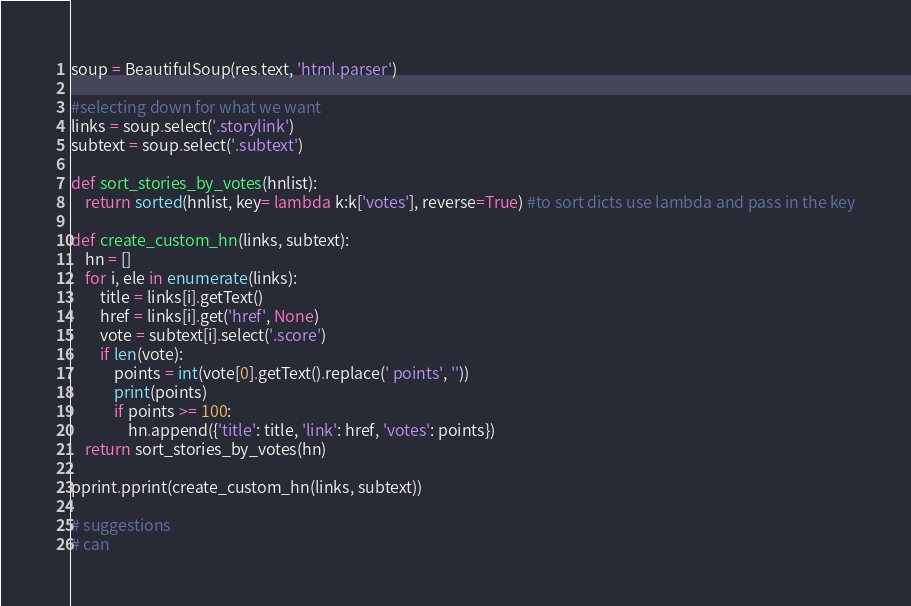Convert code to text. <code><loc_0><loc_0><loc_500><loc_500><_Python_>soup = BeautifulSoup(res.text, 'html.parser')

#selecting down for what we want 
links = soup.select('.storylink')
subtext = soup.select('.subtext')

def sort_stories_by_votes(hnlist):
    return sorted(hnlist, key= lambda k:k['votes'], reverse=True) #to sort dicts use lambda and pass in the key

def create_custom_hn(links, subtext):
    hn = []
    for i, ele in enumerate(links):
        title = links[i].getText()
        href = links[i].get('href', None)
        vote = subtext[i].select('.score')
        if len(vote):
            points = int(vote[0].getText().replace(' points', ''))
            print(points)
            if points >= 100:
                hn.append({'title': title, 'link': href, 'votes': points})
    return sort_stories_by_votes(hn)

pprint.pprint(create_custom_hn(links, subtext))

# suggestions 
# can </code> 